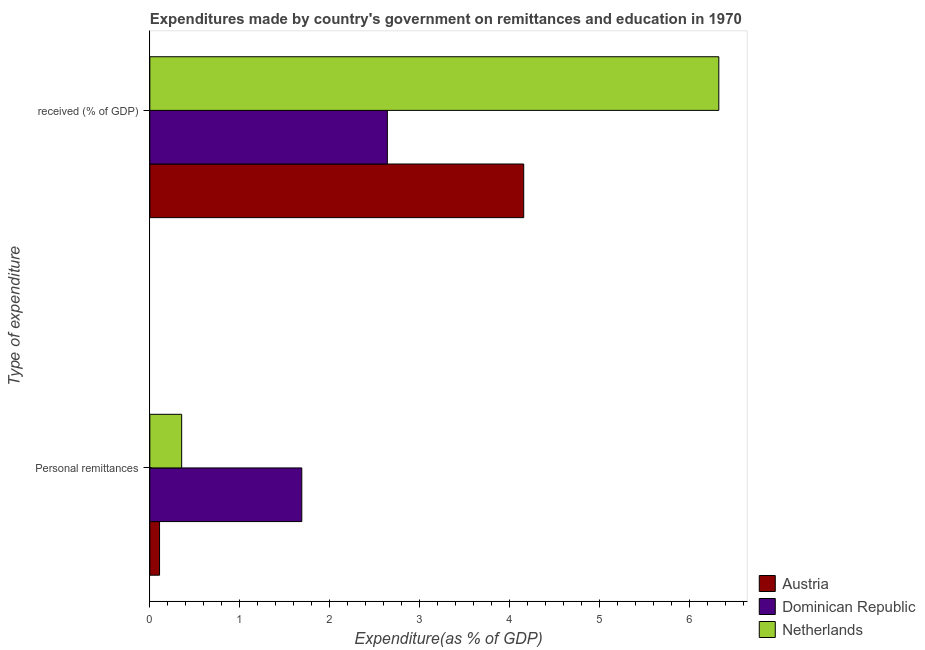How many groups of bars are there?
Provide a short and direct response. 2. Are the number of bars per tick equal to the number of legend labels?
Keep it short and to the point. Yes. What is the label of the 1st group of bars from the top?
Offer a terse response.  received (% of GDP). What is the expenditure in education in Austria?
Ensure brevity in your answer.  4.16. Across all countries, what is the maximum expenditure in education?
Offer a very short reply. 6.33. Across all countries, what is the minimum expenditure in education?
Your answer should be very brief. 2.64. In which country was the expenditure in education maximum?
Your answer should be very brief. Netherlands. In which country was the expenditure in education minimum?
Give a very brief answer. Dominican Republic. What is the total expenditure in personal remittances in the graph?
Keep it short and to the point. 2.15. What is the difference between the expenditure in personal remittances in Austria and that in Netherlands?
Your answer should be compact. -0.25. What is the difference between the expenditure in education in Austria and the expenditure in personal remittances in Netherlands?
Offer a very short reply. 3.8. What is the average expenditure in personal remittances per country?
Your answer should be compact. 0.72. What is the difference between the expenditure in education and expenditure in personal remittances in Dominican Republic?
Keep it short and to the point. 0.95. What is the ratio of the expenditure in personal remittances in Netherlands to that in Dominican Republic?
Offer a very short reply. 0.21. Is the expenditure in personal remittances in Dominican Republic less than that in Austria?
Provide a short and direct response. No. What does the 2nd bar from the top in  received (% of GDP) represents?
Offer a very short reply. Dominican Republic. How many bars are there?
Your answer should be very brief. 6. Are all the bars in the graph horizontal?
Your answer should be very brief. Yes. Are the values on the major ticks of X-axis written in scientific E-notation?
Offer a terse response. No. Does the graph contain grids?
Your answer should be compact. No. Where does the legend appear in the graph?
Your response must be concise. Bottom right. How are the legend labels stacked?
Give a very brief answer. Vertical. What is the title of the graph?
Make the answer very short. Expenditures made by country's government on remittances and education in 1970. What is the label or title of the X-axis?
Offer a terse response. Expenditure(as % of GDP). What is the label or title of the Y-axis?
Your answer should be very brief. Type of expenditure. What is the Expenditure(as % of GDP) of Austria in Personal remittances?
Provide a succinct answer. 0.11. What is the Expenditure(as % of GDP) in Dominican Republic in Personal remittances?
Provide a succinct answer. 1.69. What is the Expenditure(as % of GDP) of Netherlands in Personal remittances?
Make the answer very short. 0.35. What is the Expenditure(as % of GDP) of Austria in  received (% of GDP)?
Keep it short and to the point. 4.16. What is the Expenditure(as % of GDP) of Dominican Republic in  received (% of GDP)?
Provide a short and direct response. 2.64. What is the Expenditure(as % of GDP) in Netherlands in  received (% of GDP)?
Your response must be concise. 6.33. Across all Type of expenditure, what is the maximum Expenditure(as % of GDP) in Austria?
Offer a terse response. 4.16. Across all Type of expenditure, what is the maximum Expenditure(as % of GDP) in Dominican Republic?
Keep it short and to the point. 2.64. Across all Type of expenditure, what is the maximum Expenditure(as % of GDP) of Netherlands?
Keep it short and to the point. 6.33. Across all Type of expenditure, what is the minimum Expenditure(as % of GDP) of Austria?
Ensure brevity in your answer.  0.11. Across all Type of expenditure, what is the minimum Expenditure(as % of GDP) of Dominican Republic?
Keep it short and to the point. 1.69. Across all Type of expenditure, what is the minimum Expenditure(as % of GDP) of Netherlands?
Provide a succinct answer. 0.35. What is the total Expenditure(as % of GDP) in Austria in the graph?
Your answer should be very brief. 4.27. What is the total Expenditure(as % of GDP) in Dominican Republic in the graph?
Make the answer very short. 4.33. What is the total Expenditure(as % of GDP) in Netherlands in the graph?
Keep it short and to the point. 6.68. What is the difference between the Expenditure(as % of GDP) in Austria in Personal remittances and that in  received (% of GDP)?
Your answer should be compact. -4.05. What is the difference between the Expenditure(as % of GDP) of Dominican Republic in Personal remittances and that in  received (% of GDP)?
Your answer should be compact. -0.95. What is the difference between the Expenditure(as % of GDP) of Netherlands in Personal remittances and that in  received (% of GDP)?
Keep it short and to the point. -5.97. What is the difference between the Expenditure(as % of GDP) in Austria in Personal remittances and the Expenditure(as % of GDP) in Dominican Republic in  received (% of GDP)?
Offer a very short reply. -2.53. What is the difference between the Expenditure(as % of GDP) of Austria in Personal remittances and the Expenditure(as % of GDP) of Netherlands in  received (% of GDP)?
Make the answer very short. -6.22. What is the difference between the Expenditure(as % of GDP) of Dominican Republic in Personal remittances and the Expenditure(as % of GDP) of Netherlands in  received (% of GDP)?
Your answer should be compact. -4.64. What is the average Expenditure(as % of GDP) of Austria per Type of expenditure?
Give a very brief answer. 2.13. What is the average Expenditure(as % of GDP) of Dominican Republic per Type of expenditure?
Your response must be concise. 2.17. What is the average Expenditure(as % of GDP) of Netherlands per Type of expenditure?
Keep it short and to the point. 3.34. What is the difference between the Expenditure(as % of GDP) of Austria and Expenditure(as % of GDP) of Dominican Republic in Personal remittances?
Offer a very short reply. -1.58. What is the difference between the Expenditure(as % of GDP) in Austria and Expenditure(as % of GDP) in Netherlands in Personal remittances?
Offer a terse response. -0.25. What is the difference between the Expenditure(as % of GDP) in Dominican Republic and Expenditure(as % of GDP) in Netherlands in Personal remittances?
Provide a short and direct response. 1.34. What is the difference between the Expenditure(as % of GDP) in Austria and Expenditure(as % of GDP) in Dominican Republic in  received (% of GDP)?
Provide a short and direct response. 1.52. What is the difference between the Expenditure(as % of GDP) of Austria and Expenditure(as % of GDP) of Netherlands in  received (% of GDP)?
Ensure brevity in your answer.  -2.17. What is the difference between the Expenditure(as % of GDP) in Dominican Republic and Expenditure(as % of GDP) in Netherlands in  received (% of GDP)?
Give a very brief answer. -3.69. What is the ratio of the Expenditure(as % of GDP) in Austria in Personal remittances to that in  received (% of GDP)?
Give a very brief answer. 0.03. What is the ratio of the Expenditure(as % of GDP) of Dominican Republic in Personal remittances to that in  received (% of GDP)?
Give a very brief answer. 0.64. What is the ratio of the Expenditure(as % of GDP) of Netherlands in Personal remittances to that in  received (% of GDP)?
Offer a very short reply. 0.06. What is the difference between the highest and the second highest Expenditure(as % of GDP) of Austria?
Keep it short and to the point. 4.05. What is the difference between the highest and the second highest Expenditure(as % of GDP) in Dominican Republic?
Offer a terse response. 0.95. What is the difference between the highest and the second highest Expenditure(as % of GDP) in Netherlands?
Give a very brief answer. 5.97. What is the difference between the highest and the lowest Expenditure(as % of GDP) of Austria?
Make the answer very short. 4.05. What is the difference between the highest and the lowest Expenditure(as % of GDP) in Dominican Republic?
Your answer should be very brief. 0.95. What is the difference between the highest and the lowest Expenditure(as % of GDP) in Netherlands?
Keep it short and to the point. 5.97. 